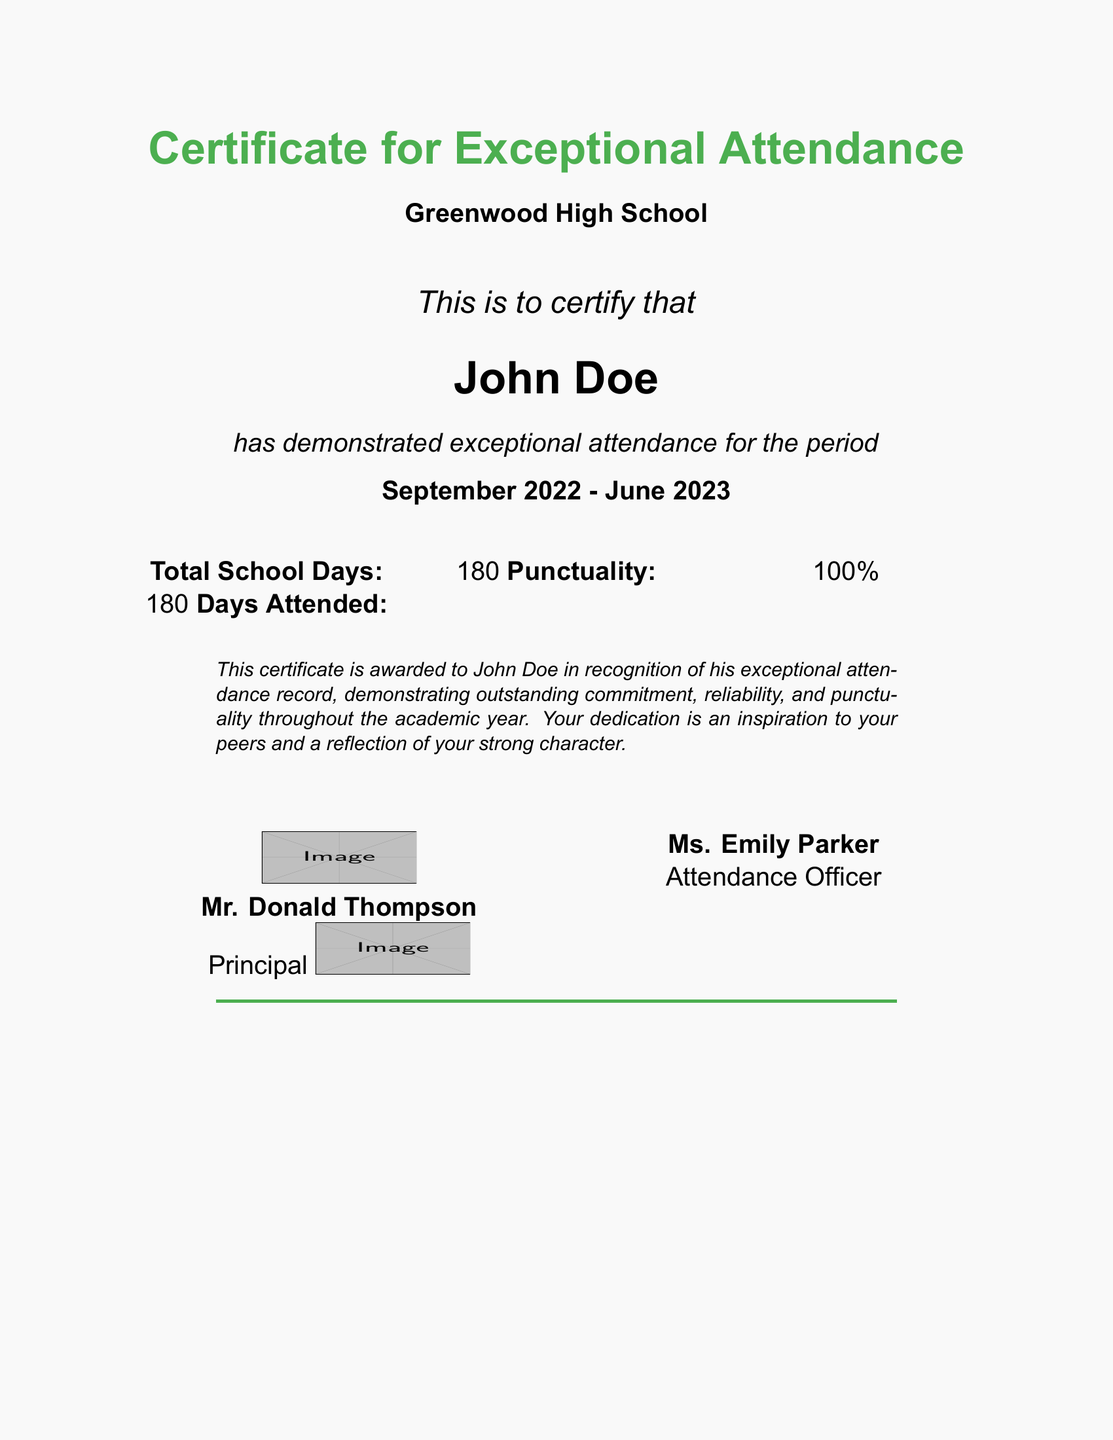What is the title of the certificate? The title is prominently displayed at the top of the document, indicating the purpose of the certificate.
Answer: Certificate for Exceptional Attendance Who is the recipient of the certificate? The recipient's name is clearly stated in a large font as the focus of the certificate.
Answer: John Doe What period does the certificate cover? The timeframe covered is mentioned just below the recipient's name, indicating the academic year for which attendance is recognized.
Answer: September 2022 - June 2023 What was the total number of school days? This number is presented in a dedicated section that summarizes the attendance statistics.
Answer: 180 What percentage of punctuality is listed? The punctuality is highlighted to reflect the recipient's adherence to time throughout the school year.
Answer: 100% What does the certificate recognize about John Doe? This is found in the commendation message that explains the significance of the award.
Answer: Exceptional attendance record Who is the principal's name stated on the certificate? The principal’s name is included to provide endorsement and legitimacy to the certificate.
Answer: Mr. Donald Thompson How many days did John Doe attend? This information is crucial for understanding the recipient's commitment to attendance.
Answer: 180 What design color is used for the border? The color used for the border is stated in the design specifications and reinforces the aesthetics of the document.
Answer: Green 